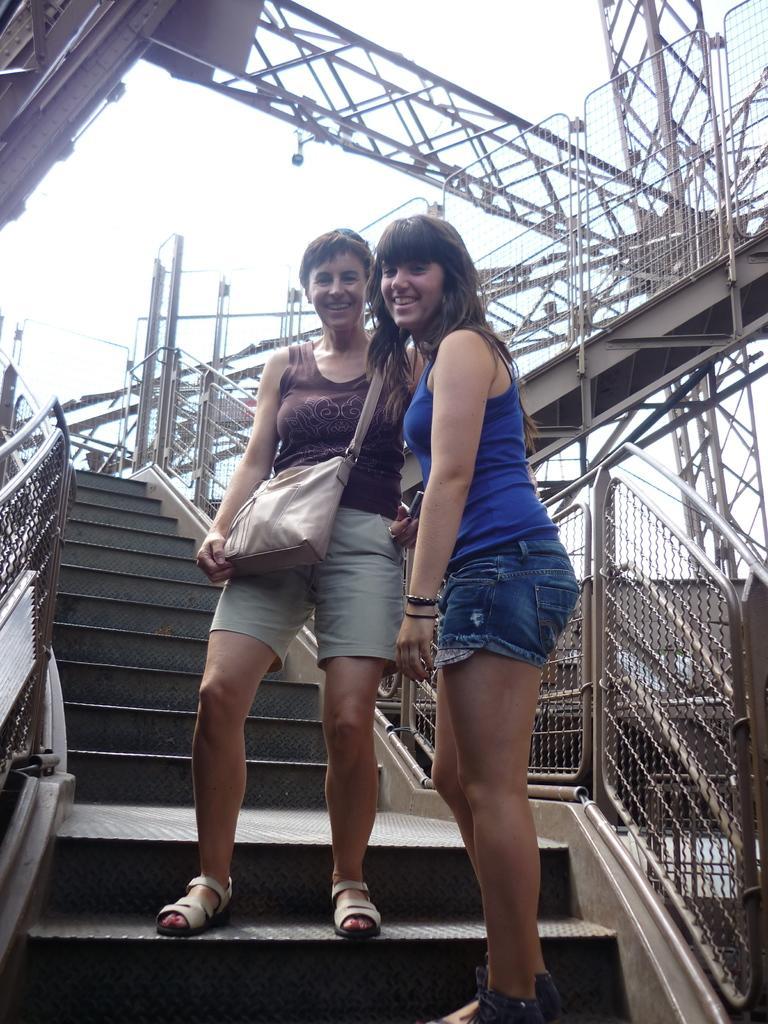Can you describe this image briefly? In this image I can see two persons standing. The person at right is wearing blue color dress and the person at left is wearing brown and gray color dress and I can also see few stairs and poles and the sky is in white color. 